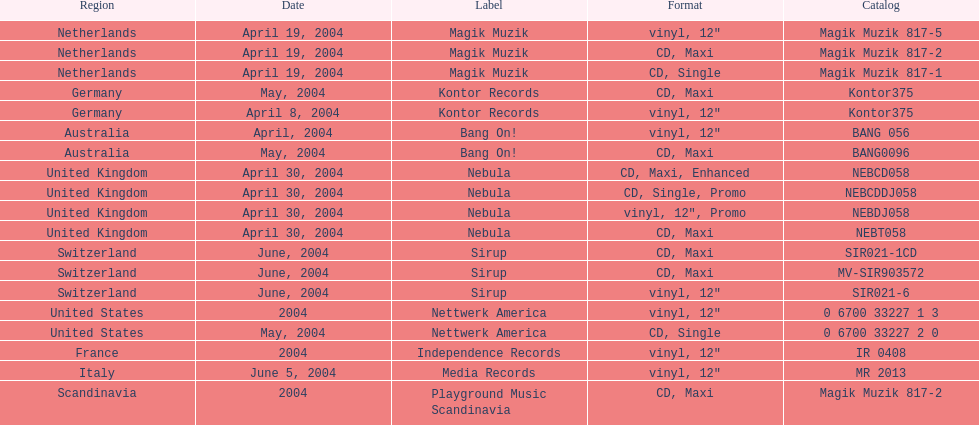What format did france use? Vinyl, 12". 